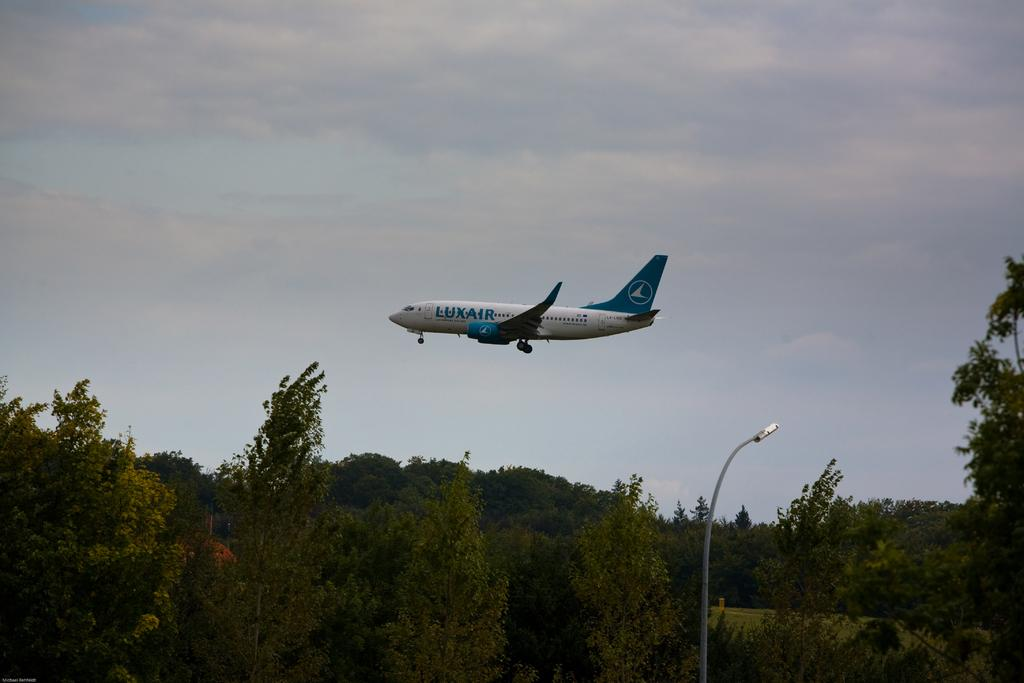<image>
Give a short and clear explanation of the subsequent image. Large white airplane with the word LUXAIR is taking off. 